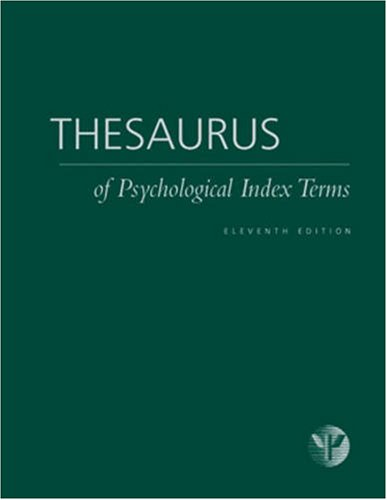Please describe the design or visual appearance of this book cover. The book cover features a deep green background with the title 'Thesaurus of Psychological Index Terms' prominently displayed in white serif font. The simplicity of the design suggests a professional and academic purpose, emphasizing the content over flashy visuals. 